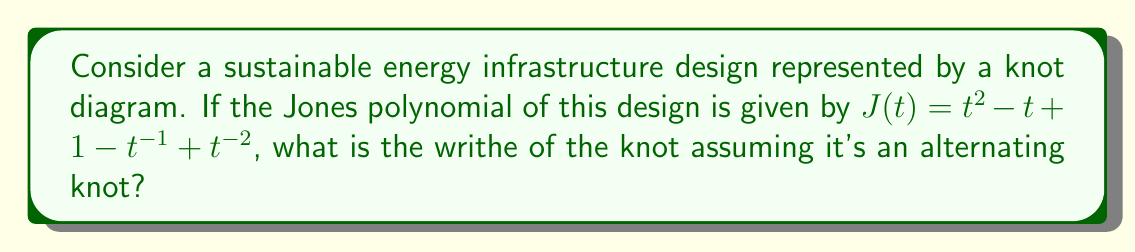Provide a solution to this math problem. To solve this problem, we'll follow these steps:

1) Recall that for an alternating knot, the span of its Jones polynomial is equal to the crossing number of the knot.

2) The span of a polynomial is the difference between its highest and lowest exponents.

3) In our Jones polynomial $J(t) = t^2 - t + 1 - t^{-1} + t^{-2}$:
   - The highest exponent is 2
   - The lowest exponent is -2

4) Therefore, the span is 2 - (-2) = 4

5) This means our alternating knot has 4 crossings.

6) For alternating knots, there's a relationship between the writhe (w), the highest exponent of the Jones polynomial (e+), and the number of crossings (n):

   $$w = e_+ - \frac{n-1}{2}$$

7) We know:
   - $e_+ = 2$ (highest exponent in our polynomial)
   - $n = 4$ (number of crossings, which we found in step 5)

8) Let's substitute these values:

   $$w = 2 - \frac{4-1}{2} = 2 - \frac{3}{2} = 2 - 1.5 = 0.5$$

Therefore, the writhe of the knot is 0.5.
Answer: 0.5 